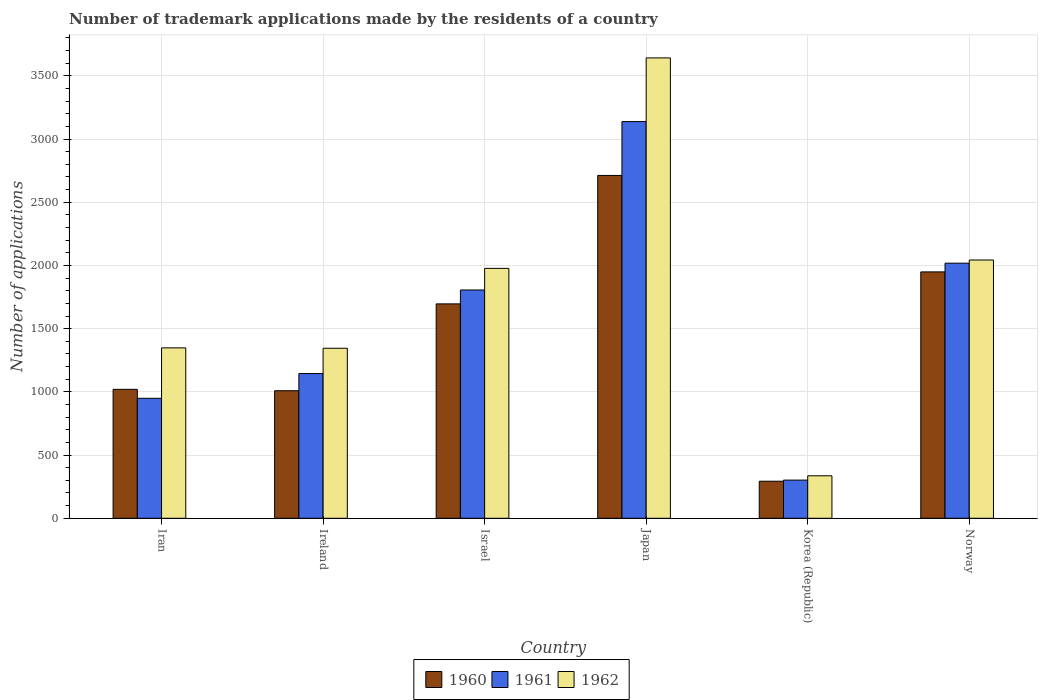How many groups of bars are there?
Your response must be concise. 6. Are the number of bars on each tick of the X-axis equal?
Offer a terse response. Yes. How many bars are there on the 4th tick from the right?
Make the answer very short. 3. What is the label of the 4th group of bars from the left?
Provide a succinct answer. Japan. What is the number of trademark applications made by the residents in 1962 in Norway?
Provide a short and direct response. 2043. Across all countries, what is the maximum number of trademark applications made by the residents in 1961?
Make the answer very short. 3138. Across all countries, what is the minimum number of trademark applications made by the residents in 1962?
Keep it short and to the point. 336. In which country was the number of trademark applications made by the residents in 1960 minimum?
Offer a terse response. Korea (Republic). What is the total number of trademark applications made by the residents in 1961 in the graph?
Keep it short and to the point. 9358. What is the difference between the number of trademark applications made by the residents in 1960 in Israel and that in Norway?
Your response must be concise. -253. What is the difference between the number of trademark applications made by the residents in 1961 in Norway and the number of trademark applications made by the residents in 1962 in Korea (Republic)?
Give a very brief answer. 1682. What is the average number of trademark applications made by the residents in 1961 per country?
Make the answer very short. 1559.67. What is the difference between the number of trademark applications made by the residents of/in 1962 and number of trademark applications made by the residents of/in 1961 in Ireland?
Offer a very short reply. 200. What is the ratio of the number of trademark applications made by the residents in 1960 in Iran to that in Japan?
Your response must be concise. 0.38. Is the number of trademark applications made by the residents in 1962 in Israel less than that in Norway?
Your response must be concise. Yes. What is the difference between the highest and the second highest number of trademark applications made by the residents in 1960?
Keep it short and to the point. 763. What is the difference between the highest and the lowest number of trademark applications made by the residents in 1962?
Provide a short and direct response. 3306. In how many countries, is the number of trademark applications made by the residents in 1960 greater than the average number of trademark applications made by the residents in 1960 taken over all countries?
Give a very brief answer. 3. Is the sum of the number of trademark applications made by the residents in 1961 in Israel and Norway greater than the maximum number of trademark applications made by the residents in 1962 across all countries?
Keep it short and to the point. Yes. What does the 3rd bar from the right in Norway represents?
Offer a very short reply. 1960. How many countries are there in the graph?
Provide a short and direct response. 6. What is the difference between two consecutive major ticks on the Y-axis?
Ensure brevity in your answer.  500. Where does the legend appear in the graph?
Offer a very short reply. Bottom center. How many legend labels are there?
Offer a terse response. 3. How are the legend labels stacked?
Give a very brief answer. Horizontal. What is the title of the graph?
Make the answer very short. Number of trademark applications made by the residents of a country. What is the label or title of the Y-axis?
Your response must be concise. Number of applications. What is the Number of applications of 1960 in Iran?
Keep it short and to the point. 1020. What is the Number of applications in 1961 in Iran?
Your response must be concise. 949. What is the Number of applications of 1962 in Iran?
Your response must be concise. 1348. What is the Number of applications in 1960 in Ireland?
Offer a terse response. 1009. What is the Number of applications in 1961 in Ireland?
Provide a succinct answer. 1145. What is the Number of applications in 1962 in Ireland?
Offer a very short reply. 1345. What is the Number of applications in 1960 in Israel?
Offer a very short reply. 1696. What is the Number of applications of 1961 in Israel?
Your response must be concise. 1806. What is the Number of applications in 1962 in Israel?
Your answer should be compact. 1977. What is the Number of applications of 1960 in Japan?
Give a very brief answer. 2712. What is the Number of applications of 1961 in Japan?
Give a very brief answer. 3138. What is the Number of applications of 1962 in Japan?
Offer a very short reply. 3642. What is the Number of applications of 1960 in Korea (Republic)?
Ensure brevity in your answer.  293. What is the Number of applications of 1961 in Korea (Republic)?
Your answer should be very brief. 302. What is the Number of applications of 1962 in Korea (Republic)?
Offer a very short reply. 336. What is the Number of applications of 1960 in Norway?
Make the answer very short. 1949. What is the Number of applications in 1961 in Norway?
Provide a succinct answer. 2018. What is the Number of applications in 1962 in Norway?
Provide a succinct answer. 2043. Across all countries, what is the maximum Number of applications of 1960?
Ensure brevity in your answer.  2712. Across all countries, what is the maximum Number of applications in 1961?
Offer a very short reply. 3138. Across all countries, what is the maximum Number of applications in 1962?
Offer a terse response. 3642. Across all countries, what is the minimum Number of applications of 1960?
Keep it short and to the point. 293. Across all countries, what is the minimum Number of applications in 1961?
Your response must be concise. 302. Across all countries, what is the minimum Number of applications of 1962?
Provide a succinct answer. 336. What is the total Number of applications in 1960 in the graph?
Ensure brevity in your answer.  8679. What is the total Number of applications of 1961 in the graph?
Give a very brief answer. 9358. What is the total Number of applications of 1962 in the graph?
Make the answer very short. 1.07e+04. What is the difference between the Number of applications of 1960 in Iran and that in Ireland?
Offer a terse response. 11. What is the difference between the Number of applications in 1961 in Iran and that in Ireland?
Make the answer very short. -196. What is the difference between the Number of applications in 1960 in Iran and that in Israel?
Your response must be concise. -676. What is the difference between the Number of applications in 1961 in Iran and that in Israel?
Provide a short and direct response. -857. What is the difference between the Number of applications of 1962 in Iran and that in Israel?
Provide a succinct answer. -629. What is the difference between the Number of applications in 1960 in Iran and that in Japan?
Keep it short and to the point. -1692. What is the difference between the Number of applications in 1961 in Iran and that in Japan?
Ensure brevity in your answer.  -2189. What is the difference between the Number of applications of 1962 in Iran and that in Japan?
Provide a short and direct response. -2294. What is the difference between the Number of applications of 1960 in Iran and that in Korea (Republic)?
Your answer should be compact. 727. What is the difference between the Number of applications in 1961 in Iran and that in Korea (Republic)?
Offer a very short reply. 647. What is the difference between the Number of applications in 1962 in Iran and that in Korea (Republic)?
Your answer should be compact. 1012. What is the difference between the Number of applications in 1960 in Iran and that in Norway?
Make the answer very short. -929. What is the difference between the Number of applications of 1961 in Iran and that in Norway?
Offer a very short reply. -1069. What is the difference between the Number of applications of 1962 in Iran and that in Norway?
Keep it short and to the point. -695. What is the difference between the Number of applications in 1960 in Ireland and that in Israel?
Provide a succinct answer. -687. What is the difference between the Number of applications of 1961 in Ireland and that in Israel?
Give a very brief answer. -661. What is the difference between the Number of applications in 1962 in Ireland and that in Israel?
Your response must be concise. -632. What is the difference between the Number of applications in 1960 in Ireland and that in Japan?
Offer a very short reply. -1703. What is the difference between the Number of applications in 1961 in Ireland and that in Japan?
Ensure brevity in your answer.  -1993. What is the difference between the Number of applications in 1962 in Ireland and that in Japan?
Keep it short and to the point. -2297. What is the difference between the Number of applications of 1960 in Ireland and that in Korea (Republic)?
Your answer should be very brief. 716. What is the difference between the Number of applications of 1961 in Ireland and that in Korea (Republic)?
Provide a succinct answer. 843. What is the difference between the Number of applications of 1962 in Ireland and that in Korea (Republic)?
Give a very brief answer. 1009. What is the difference between the Number of applications in 1960 in Ireland and that in Norway?
Your response must be concise. -940. What is the difference between the Number of applications in 1961 in Ireland and that in Norway?
Ensure brevity in your answer.  -873. What is the difference between the Number of applications in 1962 in Ireland and that in Norway?
Offer a very short reply. -698. What is the difference between the Number of applications of 1960 in Israel and that in Japan?
Your answer should be compact. -1016. What is the difference between the Number of applications of 1961 in Israel and that in Japan?
Offer a very short reply. -1332. What is the difference between the Number of applications in 1962 in Israel and that in Japan?
Provide a short and direct response. -1665. What is the difference between the Number of applications in 1960 in Israel and that in Korea (Republic)?
Your answer should be very brief. 1403. What is the difference between the Number of applications in 1961 in Israel and that in Korea (Republic)?
Keep it short and to the point. 1504. What is the difference between the Number of applications of 1962 in Israel and that in Korea (Republic)?
Your answer should be compact. 1641. What is the difference between the Number of applications in 1960 in Israel and that in Norway?
Keep it short and to the point. -253. What is the difference between the Number of applications in 1961 in Israel and that in Norway?
Keep it short and to the point. -212. What is the difference between the Number of applications in 1962 in Israel and that in Norway?
Provide a short and direct response. -66. What is the difference between the Number of applications in 1960 in Japan and that in Korea (Republic)?
Make the answer very short. 2419. What is the difference between the Number of applications in 1961 in Japan and that in Korea (Republic)?
Give a very brief answer. 2836. What is the difference between the Number of applications in 1962 in Japan and that in Korea (Republic)?
Offer a terse response. 3306. What is the difference between the Number of applications of 1960 in Japan and that in Norway?
Keep it short and to the point. 763. What is the difference between the Number of applications of 1961 in Japan and that in Norway?
Your response must be concise. 1120. What is the difference between the Number of applications of 1962 in Japan and that in Norway?
Offer a very short reply. 1599. What is the difference between the Number of applications in 1960 in Korea (Republic) and that in Norway?
Offer a terse response. -1656. What is the difference between the Number of applications of 1961 in Korea (Republic) and that in Norway?
Offer a very short reply. -1716. What is the difference between the Number of applications of 1962 in Korea (Republic) and that in Norway?
Make the answer very short. -1707. What is the difference between the Number of applications in 1960 in Iran and the Number of applications in 1961 in Ireland?
Make the answer very short. -125. What is the difference between the Number of applications of 1960 in Iran and the Number of applications of 1962 in Ireland?
Make the answer very short. -325. What is the difference between the Number of applications of 1961 in Iran and the Number of applications of 1962 in Ireland?
Offer a terse response. -396. What is the difference between the Number of applications of 1960 in Iran and the Number of applications of 1961 in Israel?
Give a very brief answer. -786. What is the difference between the Number of applications in 1960 in Iran and the Number of applications in 1962 in Israel?
Your response must be concise. -957. What is the difference between the Number of applications of 1961 in Iran and the Number of applications of 1962 in Israel?
Keep it short and to the point. -1028. What is the difference between the Number of applications in 1960 in Iran and the Number of applications in 1961 in Japan?
Make the answer very short. -2118. What is the difference between the Number of applications of 1960 in Iran and the Number of applications of 1962 in Japan?
Your answer should be compact. -2622. What is the difference between the Number of applications in 1961 in Iran and the Number of applications in 1962 in Japan?
Ensure brevity in your answer.  -2693. What is the difference between the Number of applications of 1960 in Iran and the Number of applications of 1961 in Korea (Republic)?
Offer a terse response. 718. What is the difference between the Number of applications of 1960 in Iran and the Number of applications of 1962 in Korea (Republic)?
Provide a succinct answer. 684. What is the difference between the Number of applications of 1961 in Iran and the Number of applications of 1962 in Korea (Republic)?
Keep it short and to the point. 613. What is the difference between the Number of applications of 1960 in Iran and the Number of applications of 1961 in Norway?
Provide a short and direct response. -998. What is the difference between the Number of applications in 1960 in Iran and the Number of applications in 1962 in Norway?
Keep it short and to the point. -1023. What is the difference between the Number of applications of 1961 in Iran and the Number of applications of 1962 in Norway?
Your response must be concise. -1094. What is the difference between the Number of applications of 1960 in Ireland and the Number of applications of 1961 in Israel?
Offer a terse response. -797. What is the difference between the Number of applications in 1960 in Ireland and the Number of applications in 1962 in Israel?
Offer a terse response. -968. What is the difference between the Number of applications of 1961 in Ireland and the Number of applications of 1962 in Israel?
Keep it short and to the point. -832. What is the difference between the Number of applications of 1960 in Ireland and the Number of applications of 1961 in Japan?
Offer a terse response. -2129. What is the difference between the Number of applications of 1960 in Ireland and the Number of applications of 1962 in Japan?
Keep it short and to the point. -2633. What is the difference between the Number of applications in 1961 in Ireland and the Number of applications in 1962 in Japan?
Your answer should be compact. -2497. What is the difference between the Number of applications of 1960 in Ireland and the Number of applications of 1961 in Korea (Republic)?
Give a very brief answer. 707. What is the difference between the Number of applications of 1960 in Ireland and the Number of applications of 1962 in Korea (Republic)?
Provide a short and direct response. 673. What is the difference between the Number of applications of 1961 in Ireland and the Number of applications of 1962 in Korea (Republic)?
Your answer should be compact. 809. What is the difference between the Number of applications in 1960 in Ireland and the Number of applications in 1961 in Norway?
Your answer should be very brief. -1009. What is the difference between the Number of applications in 1960 in Ireland and the Number of applications in 1962 in Norway?
Provide a short and direct response. -1034. What is the difference between the Number of applications in 1961 in Ireland and the Number of applications in 1962 in Norway?
Give a very brief answer. -898. What is the difference between the Number of applications of 1960 in Israel and the Number of applications of 1961 in Japan?
Keep it short and to the point. -1442. What is the difference between the Number of applications in 1960 in Israel and the Number of applications in 1962 in Japan?
Your answer should be compact. -1946. What is the difference between the Number of applications in 1961 in Israel and the Number of applications in 1962 in Japan?
Your response must be concise. -1836. What is the difference between the Number of applications of 1960 in Israel and the Number of applications of 1961 in Korea (Republic)?
Offer a terse response. 1394. What is the difference between the Number of applications of 1960 in Israel and the Number of applications of 1962 in Korea (Republic)?
Make the answer very short. 1360. What is the difference between the Number of applications of 1961 in Israel and the Number of applications of 1962 in Korea (Republic)?
Keep it short and to the point. 1470. What is the difference between the Number of applications of 1960 in Israel and the Number of applications of 1961 in Norway?
Make the answer very short. -322. What is the difference between the Number of applications of 1960 in Israel and the Number of applications of 1962 in Norway?
Offer a terse response. -347. What is the difference between the Number of applications in 1961 in Israel and the Number of applications in 1962 in Norway?
Ensure brevity in your answer.  -237. What is the difference between the Number of applications in 1960 in Japan and the Number of applications in 1961 in Korea (Republic)?
Provide a short and direct response. 2410. What is the difference between the Number of applications in 1960 in Japan and the Number of applications in 1962 in Korea (Republic)?
Give a very brief answer. 2376. What is the difference between the Number of applications in 1961 in Japan and the Number of applications in 1962 in Korea (Republic)?
Provide a short and direct response. 2802. What is the difference between the Number of applications in 1960 in Japan and the Number of applications in 1961 in Norway?
Provide a succinct answer. 694. What is the difference between the Number of applications in 1960 in Japan and the Number of applications in 1962 in Norway?
Offer a very short reply. 669. What is the difference between the Number of applications of 1961 in Japan and the Number of applications of 1962 in Norway?
Keep it short and to the point. 1095. What is the difference between the Number of applications of 1960 in Korea (Republic) and the Number of applications of 1961 in Norway?
Your answer should be compact. -1725. What is the difference between the Number of applications in 1960 in Korea (Republic) and the Number of applications in 1962 in Norway?
Ensure brevity in your answer.  -1750. What is the difference between the Number of applications in 1961 in Korea (Republic) and the Number of applications in 1962 in Norway?
Provide a succinct answer. -1741. What is the average Number of applications of 1960 per country?
Offer a terse response. 1446.5. What is the average Number of applications in 1961 per country?
Your answer should be compact. 1559.67. What is the average Number of applications in 1962 per country?
Ensure brevity in your answer.  1781.83. What is the difference between the Number of applications of 1960 and Number of applications of 1961 in Iran?
Provide a short and direct response. 71. What is the difference between the Number of applications in 1960 and Number of applications in 1962 in Iran?
Offer a terse response. -328. What is the difference between the Number of applications in 1961 and Number of applications in 1962 in Iran?
Make the answer very short. -399. What is the difference between the Number of applications of 1960 and Number of applications of 1961 in Ireland?
Make the answer very short. -136. What is the difference between the Number of applications in 1960 and Number of applications in 1962 in Ireland?
Offer a very short reply. -336. What is the difference between the Number of applications of 1961 and Number of applications of 1962 in Ireland?
Your answer should be very brief. -200. What is the difference between the Number of applications of 1960 and Number of applications of 1961 in Israel?
Your answer should be compact. -110. What is the difference between the Number of applications of 1960 and Number of applications of 1962 in Israel?
Your answer should be compact. -281. What is the difference between the Number of applications of 1961 and Number of applications of 1962 in Israel?
Provide a succinct answer. -171. What is the difference between the Number of applications of 1960 and Number of applications of 1961 in Japan?
Your response must be concise. -426. What is the difference between the Number of applications of 1960 and Number of applications of 1962 in Japan?
Offer a very short reply. -930. What is the difference between the Number of applications in 1961 and Number of applications in 1962 in Japan?
Keep it short and to the point. -504. What is the difference between the Number of applications in 1960 and Number of applications in 1962 in Korea (Republic)?
Your response must be concise. -43. What is the difference between the Number of applications in 1961 and Number of applications in 1962 in Korea (Republic)?
Make the answer very short. -34. What is the difference between the Number of applications in 1960 and Number of applications in 1961 in Norway?
Keep it short and to the point. -69. What is the difference between the Number of applications in 1960 and Number of applications in 1962 in Norway?
Your answer should be very brief. -94. What is the ratio of the Number of applications of 1960 in Iran to that in Ireland?
Ensure brevity in your answer.  1.01. What is the ratio of the Number of applications of 1961 in Iran to that in Ireland?
Provide a succinct answer. 0.83. What is the ratio of the Number of applications in 1962 in Iran to that in Ireland?
Offer a terse response. 1. What is the ratio of the Number of applications in 1960 in Iran to that in Israel?
Provide a succinct answer. 0.6. What is the ratio of the Number of applications in 1961 in Iran to that in Israel?
Give a very brief answer. 0.53. What is the ratio of the Number of applications of 1962 in Iran to that in Israel?
Give a very brief answer. 0.68. What is the ratio of the Number of applications of 1960 in Iran to that in Japan?
Provide a short and direct response. 0.38. What is the ratio of the Number of applications in 1961 in Iran to that in Japan?
Offer a very short reply. 0.3. What is the ratio of the Number of applications in 1962 in Iran to that in Japan?
Your response must be concise. 0.37. What is the ratio of the Number of applications in 1960 in Iran to that in Korea (Republic)?
Provide a short and direct response. 3.48. What is the ratio of the Number of applications of 1961 in Iran to that in Korea (Republic)?
Your answer should be compact. 3.14. What is the ratio of the Number of applications in 1962 in Iran to that in Korea (Republic)?
Your answer should be very brief. 4.01. What is the ratio of the Number of applications in 1960 in Iran to that in Norway?
Give a very brief answer. 0.52. What is the ratio of the Number of applications in 1961 in Iran to that in Norway?
Provide a short and direct response. 0.47. What is the ratio of the Number of applications of 1962 in Iran to that in Norway?
Provide a short and direct response. 0.66. What is the ratio of the Number of applications in 1960 in Ireland to that in Israel?
Your response must be concise. 0.59. What is the ratio of the Number of applications of 1961 in Ireland to that in Israel?
Your answer should be compact. 0.63. What is the ratio of the Number of applications in 1962 in Ireland to that in Israel?
Keep it short and to the point. 0.68. What is the ratio of the Number of applications in 1960 in Ireland to that in Japan?
Offer a very short reply. 0.37. What is the ratio of the Number of applications of 1961 in Ireland to that in Japan?
Offer a very short reply. 0.36. What is the ratio of the Number of applications of 1962 in Ireland to that in Japan?
Your response must be concise. 0.37. What is the ratio of the Number of applications in 1960 in Ireland to that in Korea (Republic)?
Your response must be concise. 3.44. What is the ratio of the Number of applications in 1961 in Ireland to that in Korea (Republic)?
Keep it short and to the point. 3.79. What is the ratio of the Number of applications of 1962 in Ireland to that in Korea (Republic)?
Your answer should be compact. 4. What is the ratio of the Number of applications of 1960 in Ireland to that in Norway?
Ensure brevity in your answer.  0.52. What is the ratio of the Number of applications in 1961 in Ireland to that in Norway?
Your answer should be compact. 0.57. What is the ratio of the Number of applications in 1962 in Ireland to that in Norway?
Provide a short and direct response. 0.66. What is the ratio of the Number of applications in 1960 in Israel to that in Japan?
Keep it short and to the point. 0.63. What is the ratio of the Number of applications in 1961 in Israel to that in Japan?
Offer a terse response. 0.58. What is the ratio of the Number of applications in 1962 in Israel to that in Japan?
Your answer should be compact. 0.54. What is the ratio of the Number of applications of 1960 in Israel to that in Korea (Republic)?
Ensure brevity in your answer.  5.79. What is the ratio of the Number of applications of 1961 in Israel to that in Korea (Republic)?
Provide a short and direct response. 5.98. What is the ratio of the Number of applications in 1962 in Israel to that in Korea (Republic)?
Keep it short and to the point. 5.88. What is the ratio of the Number of applications of 1960 in Israel to that in Norway?
Provide a succinct answer. 0.87. What is the ratio of the Number of applications in 1961 in Israel to that in Norway?
Offer a very short reply. 0.89. What is the ratio of the Number of applications of 1960 in Japan to that in Korea (Republic)?
Provide a short and direct response. 9.26. What is the ratio of the Number of applications in 1961 in Japan to that in Korea (Republic)?
Provide a succinct answer. 10.39. What is the ratio of the Number of applications in 1962 in Japan to that in Korea (Republic)?
Your response must be concise. 10.84. What is the ratio of the Number of applications in 1960 in Japan to that in Norway?
Provide a succinct answer. 1.39. What is the ratio of the Number of applications of 1961 in Japan to that in Norway?
Keep it short and to the point. 1.55. What is the ratio of the Number of applications of 1962 in Japan to that in Norway?
Offer a terse response. 1.78. What is the ratio of the Number of applications in 1960 in Korea (Republic) to that in Norway?
Offer a very short reply. 0.15. What is the ratio of the Number of applications in 1961 in Korea (Republic) to that in Norway?
Give a very brief answer. 0.15. What is the ratio of the Number of applications in 1962 in Korea (Republic) to that in Norway?
Provide a short and direct response. 0.16. What is the difference between the highest and the second highest Number of applications in 1960?
Your answer should be very brief. 763. What is the difference between the highest and the second highest Number of applications of 1961?
Offer a terse response. 1120. What is the difference between the highest and the second highest Number of applications of 1962?
Give a very brief answer. 1599. What is the difference between the highest and the lowest Number of applications in 1960?
Your response must be concise. 2419. What is the difference between the highest and the lowest Number of applications in 1961?
Ensure brevity in your answer.  2836. What is the difference between the highest and the lowest Number of applications in 1962?
Provide a succinct answer. 3306. 